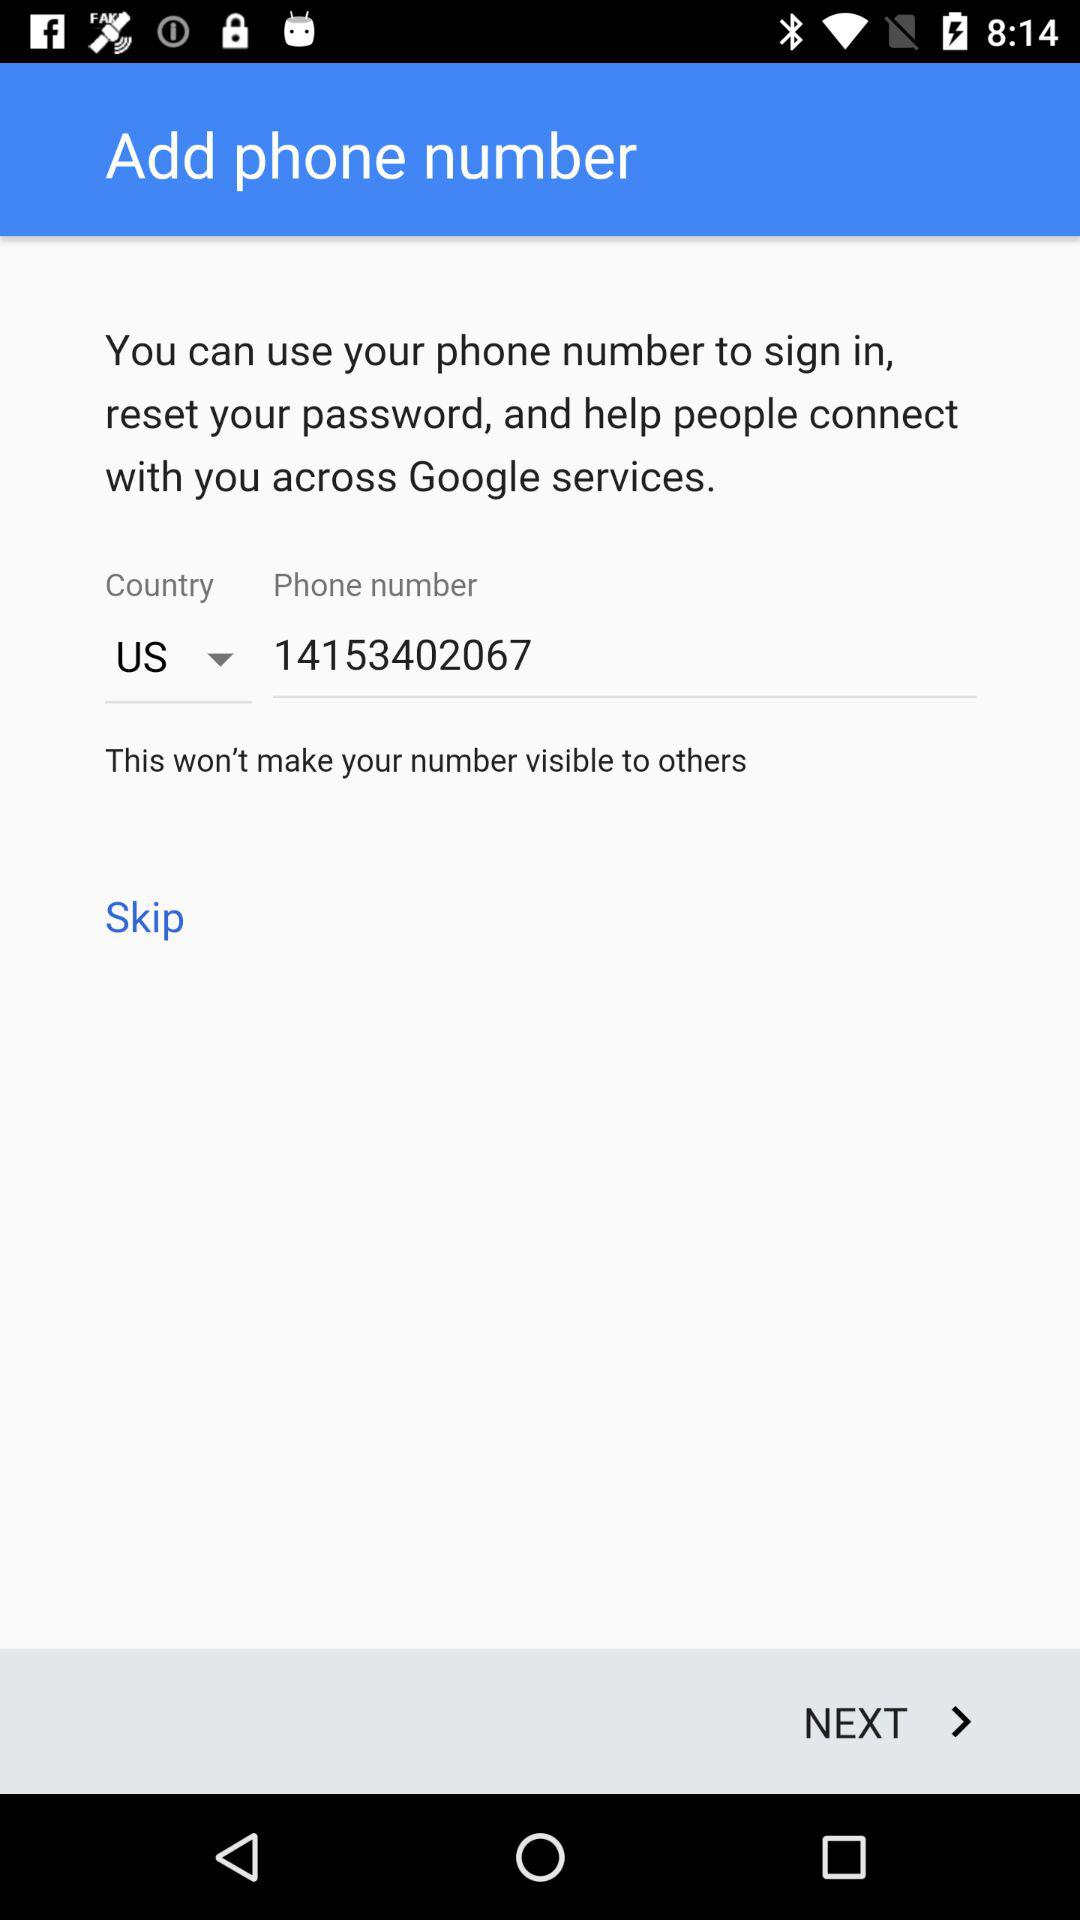What can I use for the sign in? You can use your phone number to sign in. 